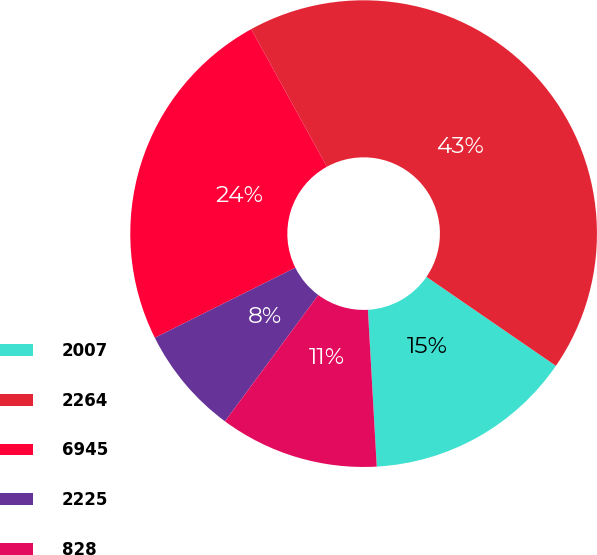<chart> <loc_0><loc_0><loc_500><loc_500><pie_chart><fcel>2007<fcel>2264<fcel>6945<fcel>2225<fcel>828<nl><fcel>14.52%<fcel>42.59%<fcel>24.37%<fcel>7.51%<fcel>11.02%<nl></chart> 